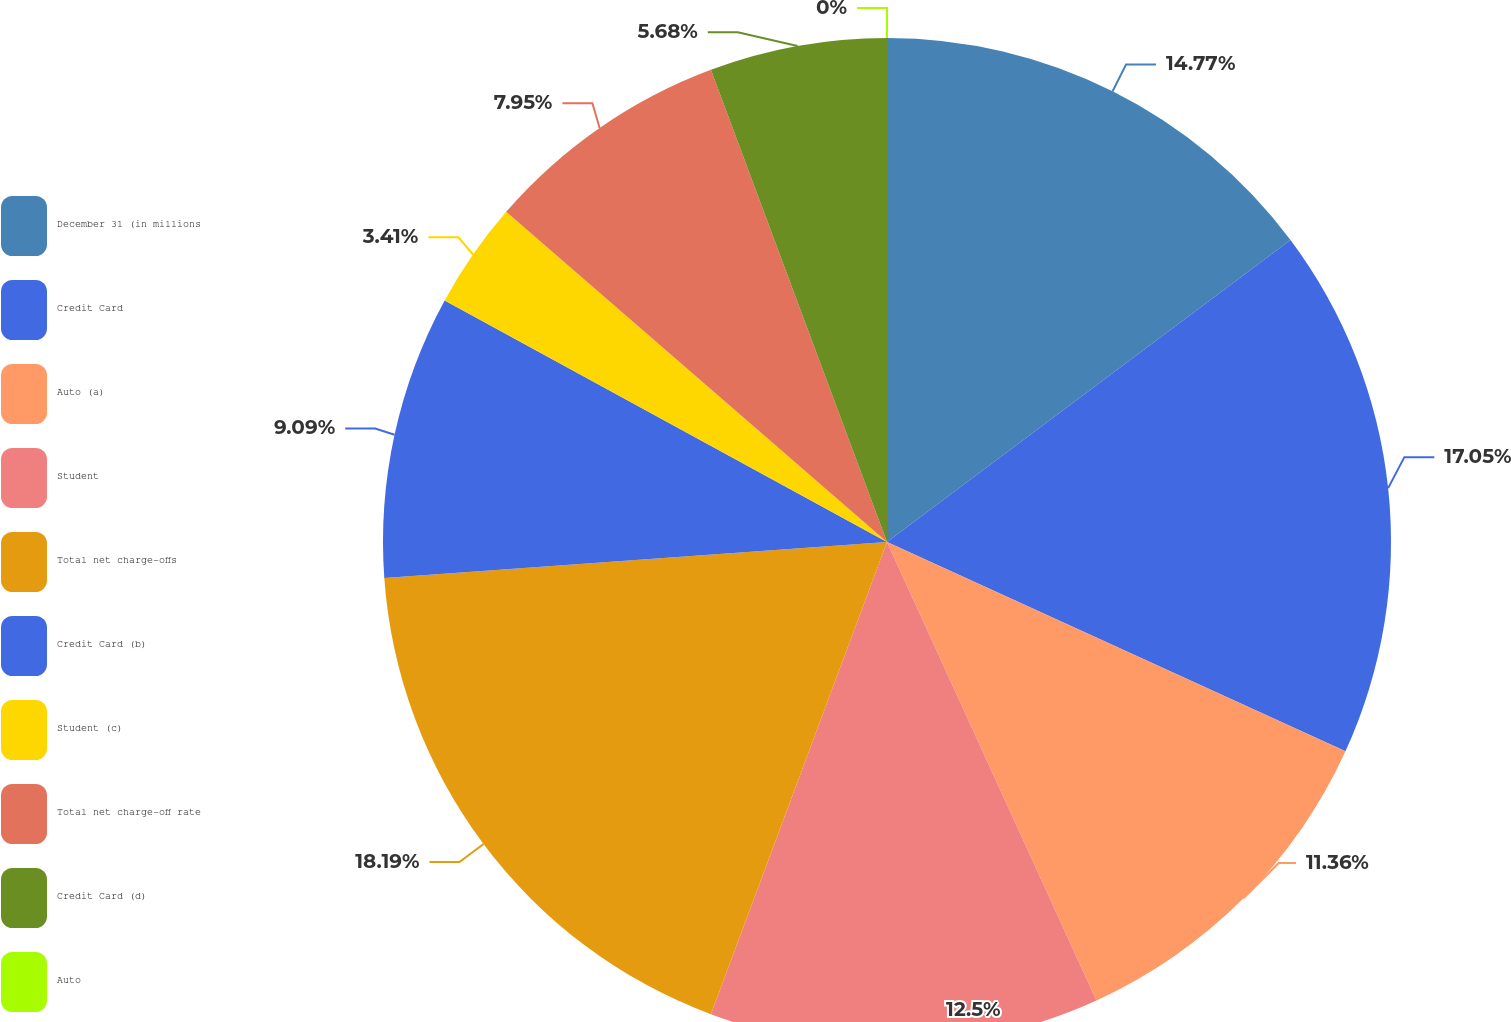<chart> <loc_0><loc_0><loc_500><loc_500><pie_chart><fcel>December 31 (in millions<fcel>Credit Card<fcel>Auto (a)<fcel>Student<fcel>Total net charge-offs<fcel>Credit Card (b)<fcel>Student (c)<fcel>Total net charge-off rate<fcel>Credit Card (d)<fcel>Auto<nl><fcel>14.77%<fcel>17.04%<fcel>11.36%<fcel>12.5%<fcel>18.18%<fcel>9.09%<fcel>3.41%<fcel>7.95%<fcel>5.68%<fcel>0.0%<nl></chart> 